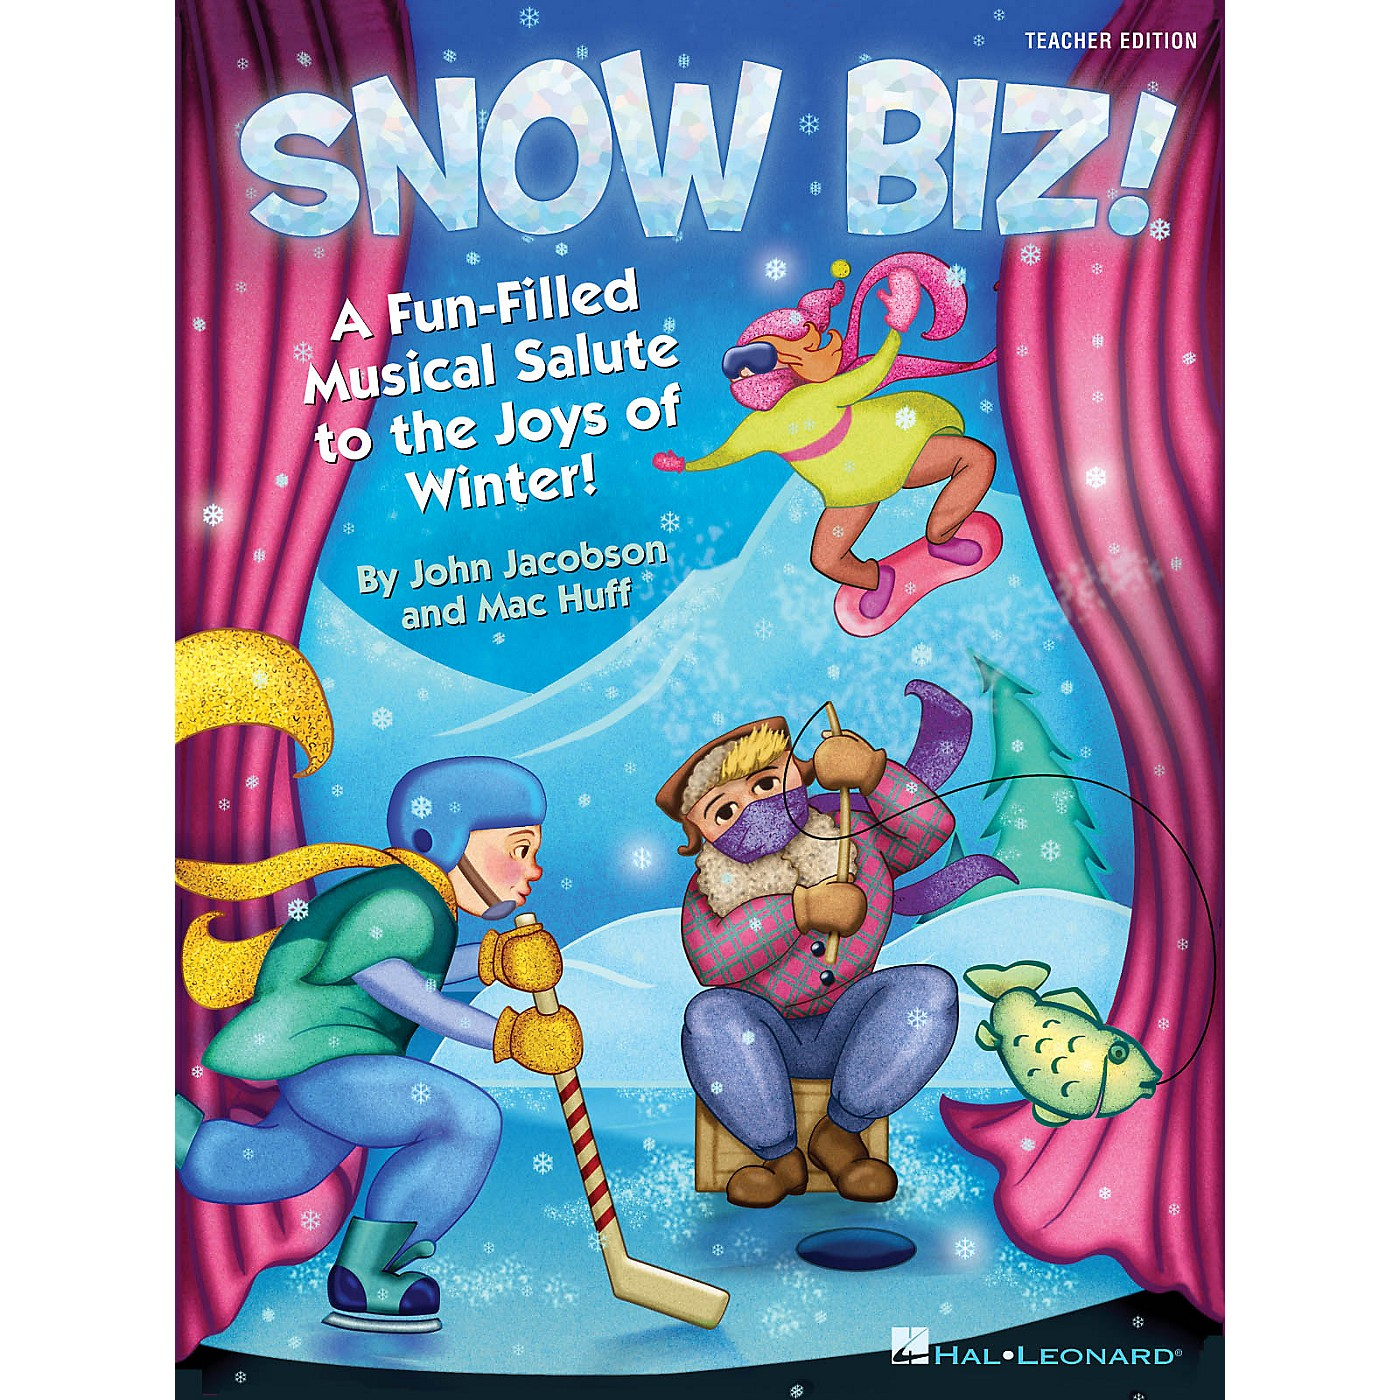What is the intended audience for this material based on the illustration style and elements present? The intended audience for this material, based on the illustration style and elements present, is likely children or families. The vibrant, cartoon-like characters, playful winter activities, and whimsical elements such as a character jumping in the air with excitement, a hockey player, and a musician ice fishing, all point towards a younger demographic. Additionally, the title 'SNOW BIZ!' and the subtitle 'A Fun-Filled Musical Salute to the Joys of Winter!' suggest that this could be an educational and entertaining piece aiming to engage young minds and their families in a joyous winter-themed musical adventure. The colorful and lively presentation indicates a focus on fun and learning, making it suitable for children. 